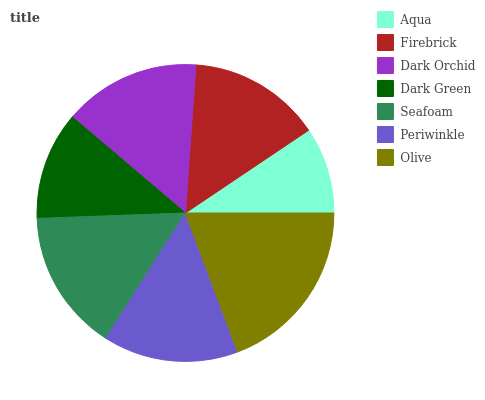Is Aqua the minimum?
Answer yes or no. Yes. Is Olive the maximum?
Answer yes or no. Yes. Is Firebrick the minimum?
Answer yes or no. No. Is Firebrick the maximum?
Answer yes or no. No. Is Firebrick greater than Aqua?
Answer yes or no. Yes. Is Aqua less than Firebrick?
Answer yes or no. Yes. Is Aqua greater than Firebrick?
Answer yes or no. No. Is Firebrick less than Aqua?
Answer yes or no. No. Is Periwinkle the high median?
Answer yes or no. Yes. Is Periwinkle the low median?
Answer yes or no. Yes. Is Olive the high median?
Answer yes or no. No. Is Firebrick the low median?
Answer yes or no. No. 